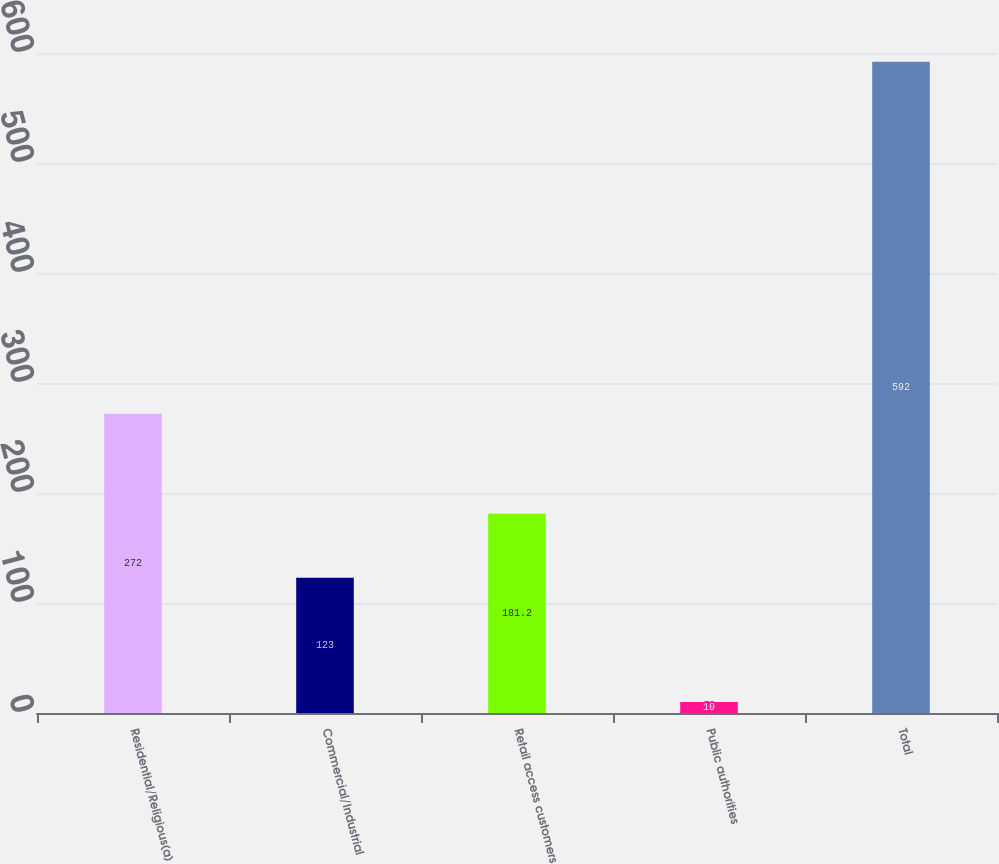Convert chart to OTSL. <chart><loc_0><loc_0><loc_500><loc_500><bar_chart><fcel>Residential/Religious(a)<fcel>Commercial/Industrial<fcel>Retail access customers<fcel>Public authorities<fcel>Total<nl><fcel>272<fcel>123<fcel>181.2<fcel>10<fcel>592<nl></chart> 